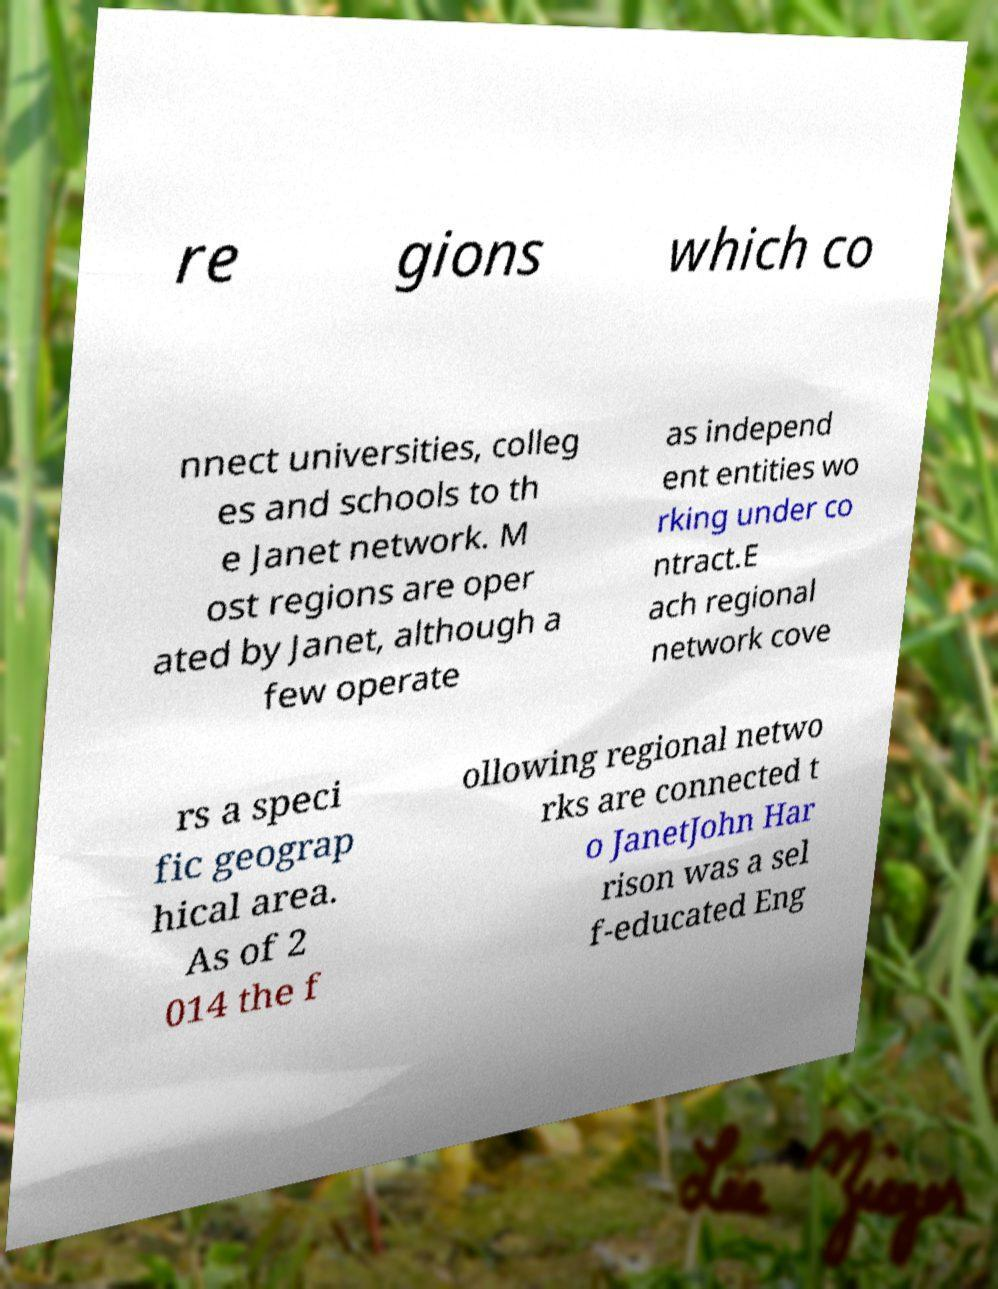I need the written content from this picture converted into text. Can you do that? re gions which co nnect universities, colleg es and schools to th e Janet network. M ost regions are oper ated by Janet, although a few operate as independ ent entities wo rking under co ntract.E ach regional network cove rs a speci fic geograp hical area. As of 2 014 the f ollowing regional netwo rks are connected t o JanetJohn Har rison was a sel f-educated Eng 